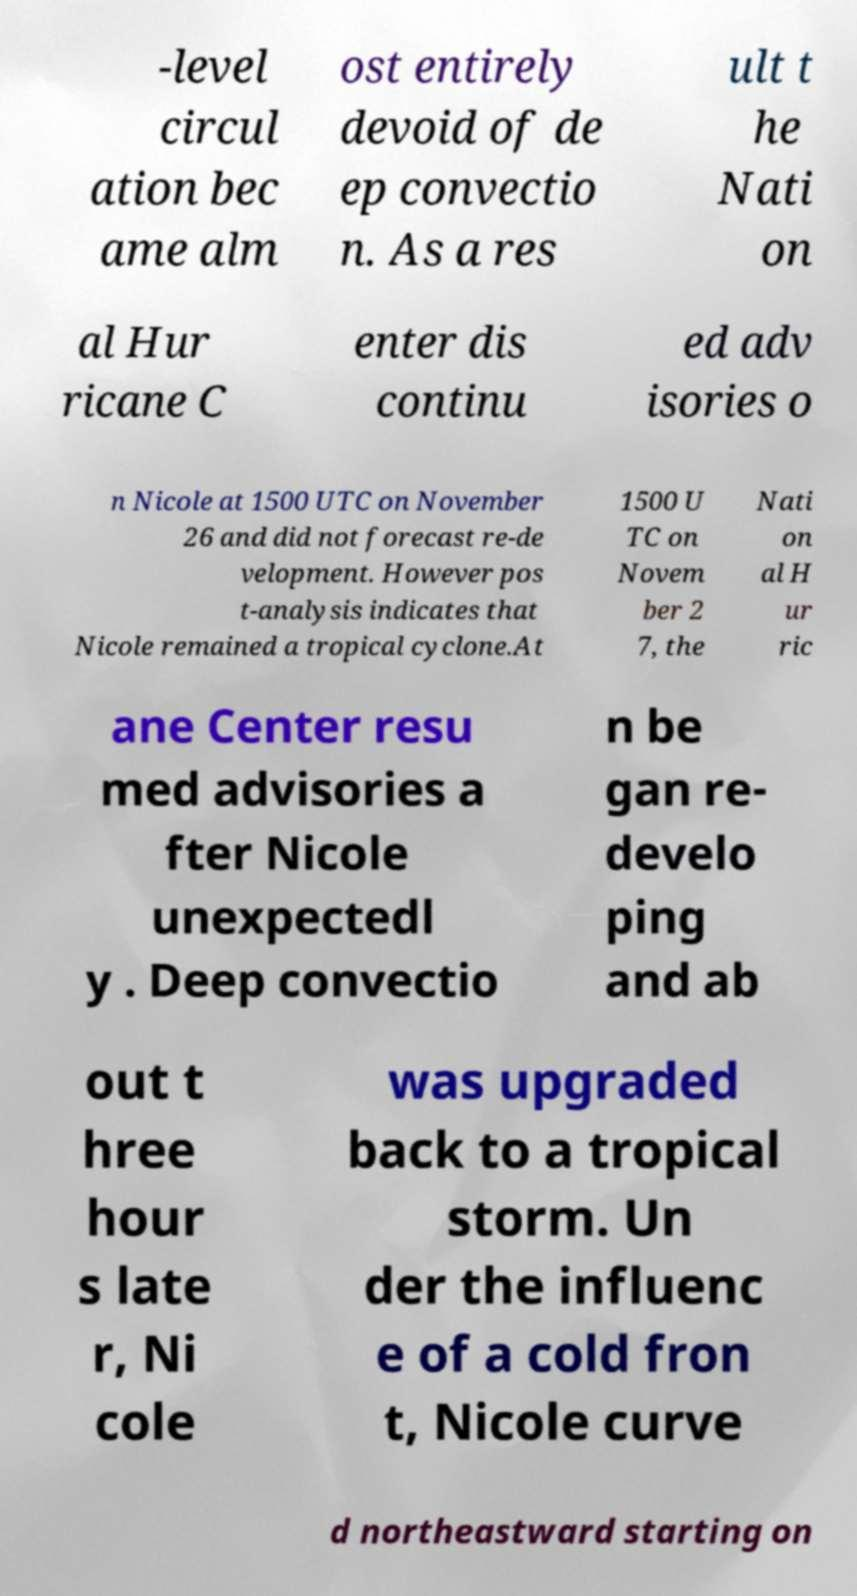Please identify and transcribe the text found in this image. -level circul ation bec ame alm ost entirely devoid of de ep convectio n. As a res ult t he Nati on al Hur ricane C enter dis continu ed adv isories o n Nicole at 1500 UTC on November 26 and did not forecast re-de velopment. However pos t-analysis indicates that Nicole remained a tropical cyclone.At 1500 U TC on Novem ber 2 7, the Nati on al H ur ric ane Center resu med advisories a fter Nicole unexpectedl y . Deep convectio n be gan re- develo ping and ab out t hree hour s late r, Ni cole was upgraded back to a tropical storm. Un der the influenc e of a cold fron t, Nicole curve d northeastward starting on 